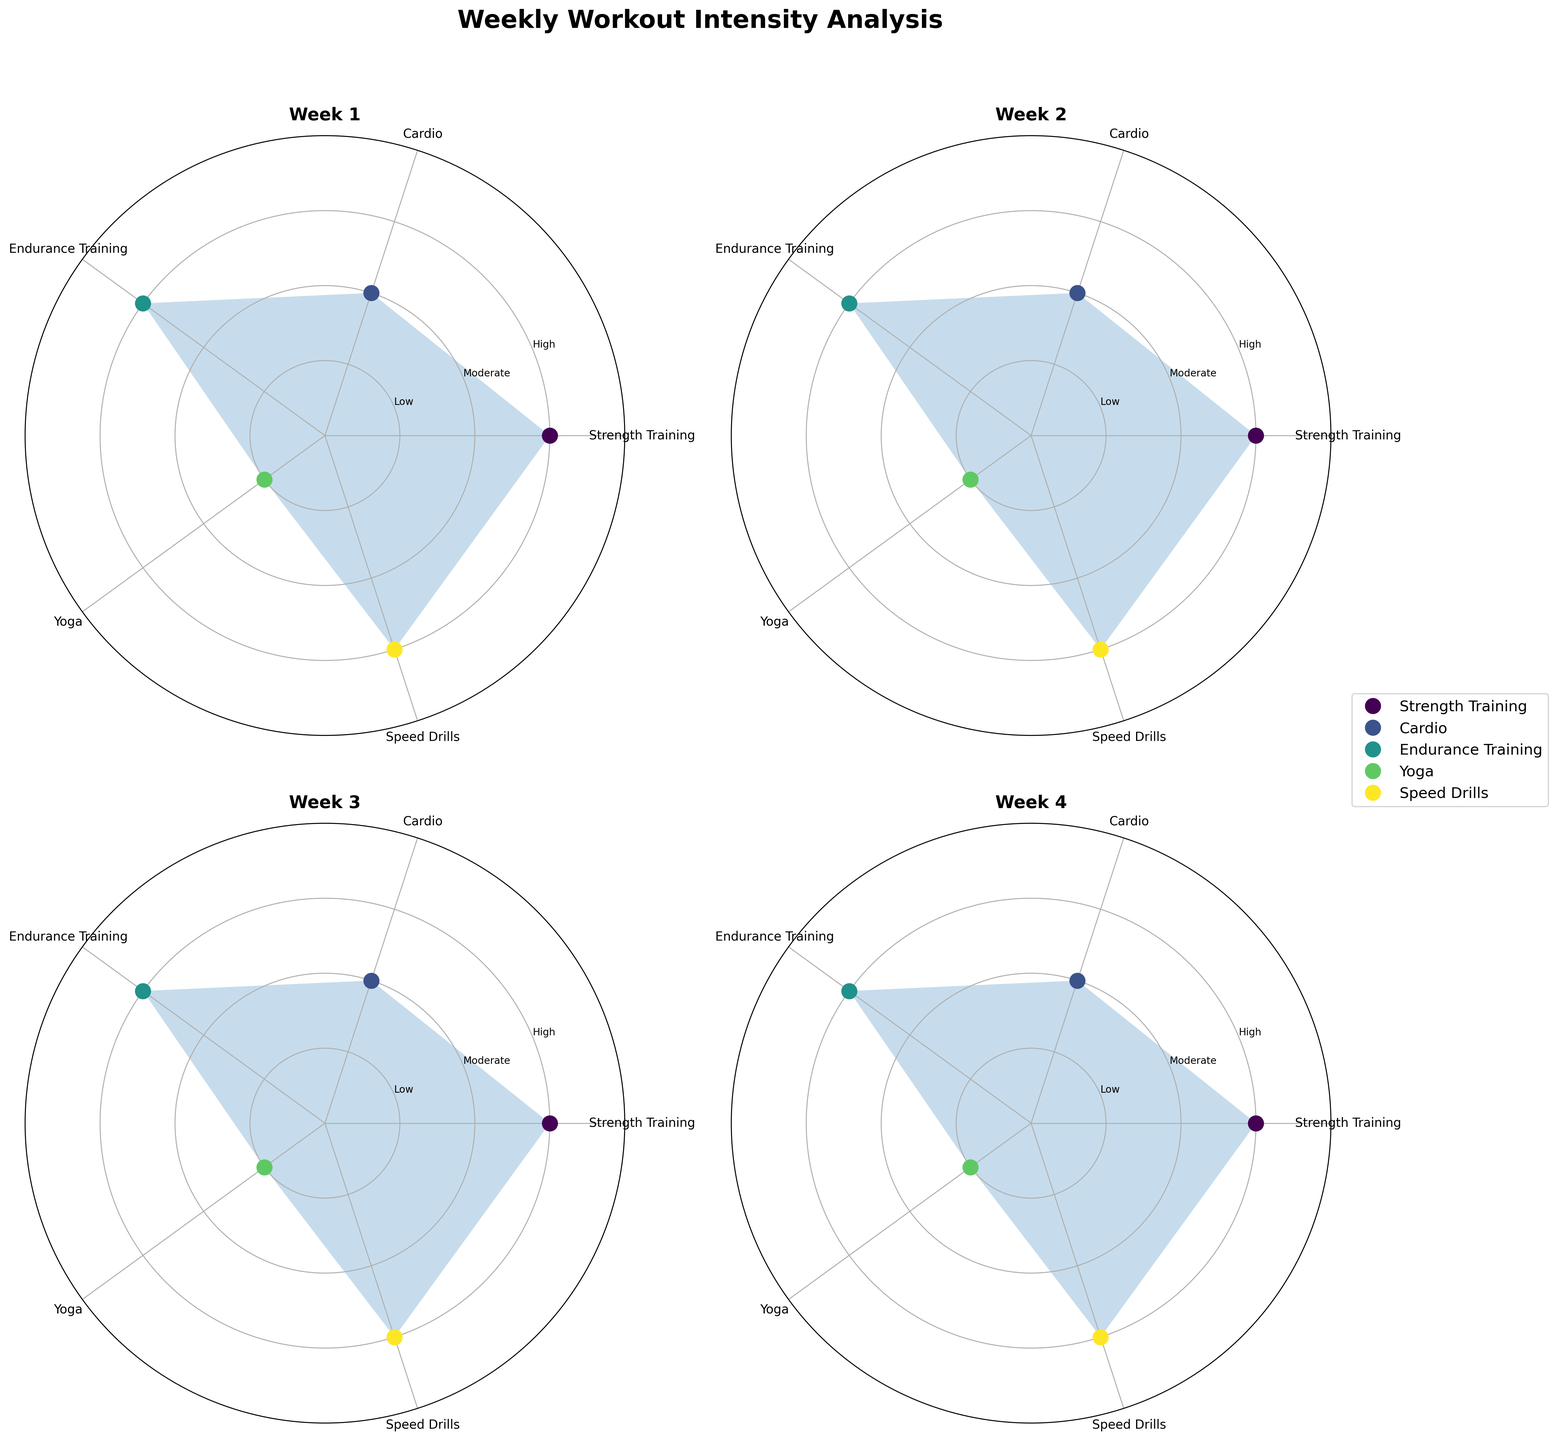What is the title of the figure? The title of the figure is placed at the top center of the plot area, displaying clearly what the figure represents.
Answer: Weekly Workout Intensity Analysis How many weeks of data are visualized in the figure? By counting the number of separate polar charts in the figure, we can determine the number of weeks represented.
Answer: 4 Which activity is consistently present across all weeks? By checking the labels on the theta axis in each subplot, we observe which activity appears across all weeks.
Answer: Strength Training Which week shows the highest intensity for Endurance Training? We check the radial (intensity) value for Endurance Training across all weeks and identify the week with the highest value.
Answer: Week 1 What is the intensity value for Yoga in Week 2? Locate Week 2's subplot, find the point representing Yoga, and read the radial axis value corresponding to the intensity.
Answer: Low Which week has the lowest overall intensity? Compare the filled areas (intensity values) for each subplot, identifying which week has the smallest filled area indicating the lowest overall intensity.
Answer: Week 2 Are there any activities that have different intensity levels across the weeks? Compare the intensity levels of the same activity across different weeks and identify any variations.
Answer: No What is the combined intensity value of Cardio and Speed Drills in Week 3? Find the intensity values for Cardio and Speed Drills in Week 3, and sum them up: Cardio (2) + Speed Drills (3).
Answer: 5 Which activity besides Rest shows moderate intensity? Moderate intensity is represented by the value 2 on the radial axis. We identify which activity besides Rest has this value in any of the weeks.
Answer: Cardio How does the intensity of Speed Drills in Week 1 compare to Week 4? Look at the intensity values for Speed Drills in Week 1 and Week 4 and compare them. Both have the same value of High (3).
Answer: Equal 